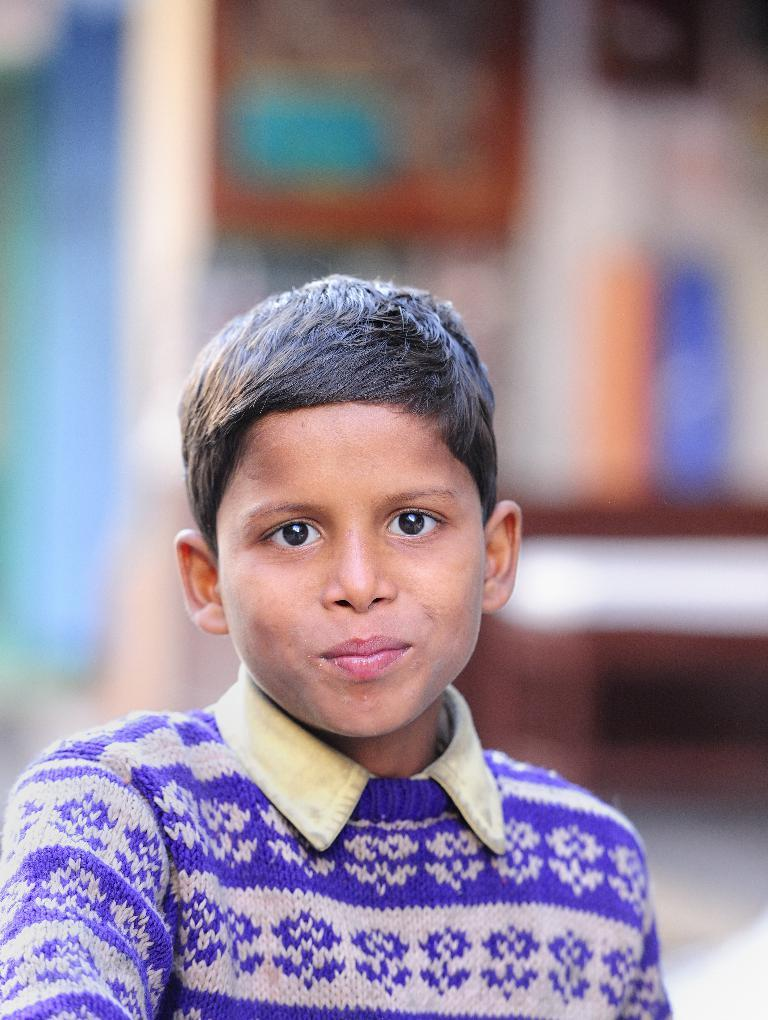What is the main subject of the image? There is a boy in the image. What is the boy wearing? The boy is wearing a t-shirt. Can you describe the background of the image? The background of the image is blurry. What type of rhythm can be heard in the background of the image? There is no rhythm or sound present in the image, as it is a still photograph. 